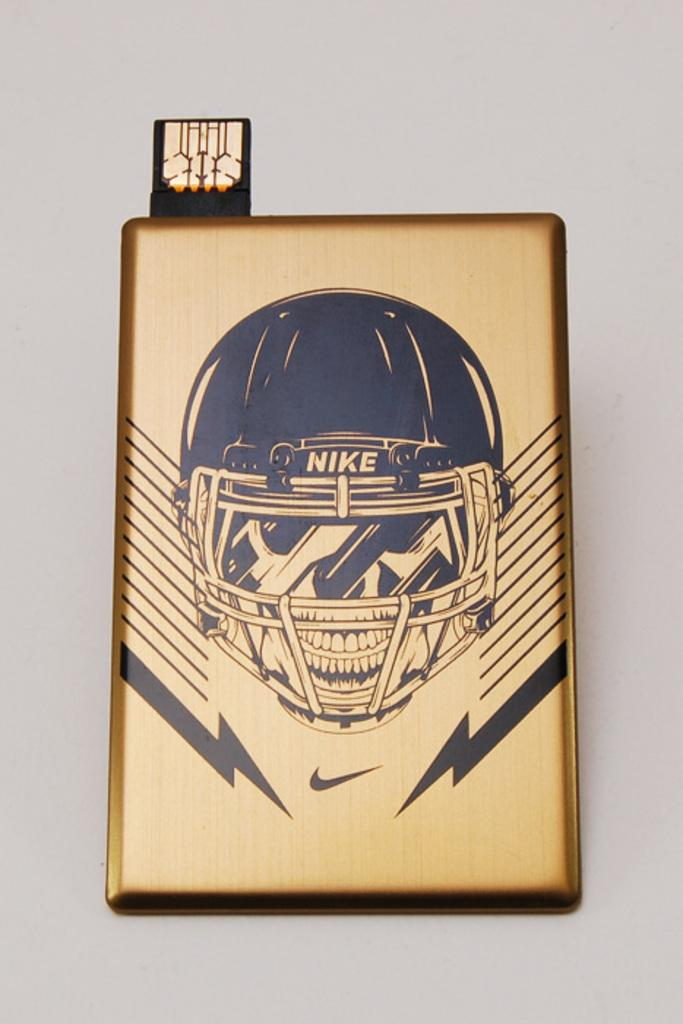What is the main subject of the image? There is an art piece in the image. What does the art piece depict? The art piece depicts a person wearing a helmet. What is the person standing on in the art piece? The person is on a brass sheet block. Where is the brass sheet block located? The brass sheet block is on a wall. What type of rod is used to join the art piece to the wall? There is no mention of a rod or any type of joining mechanism in the image or the provided facts. 